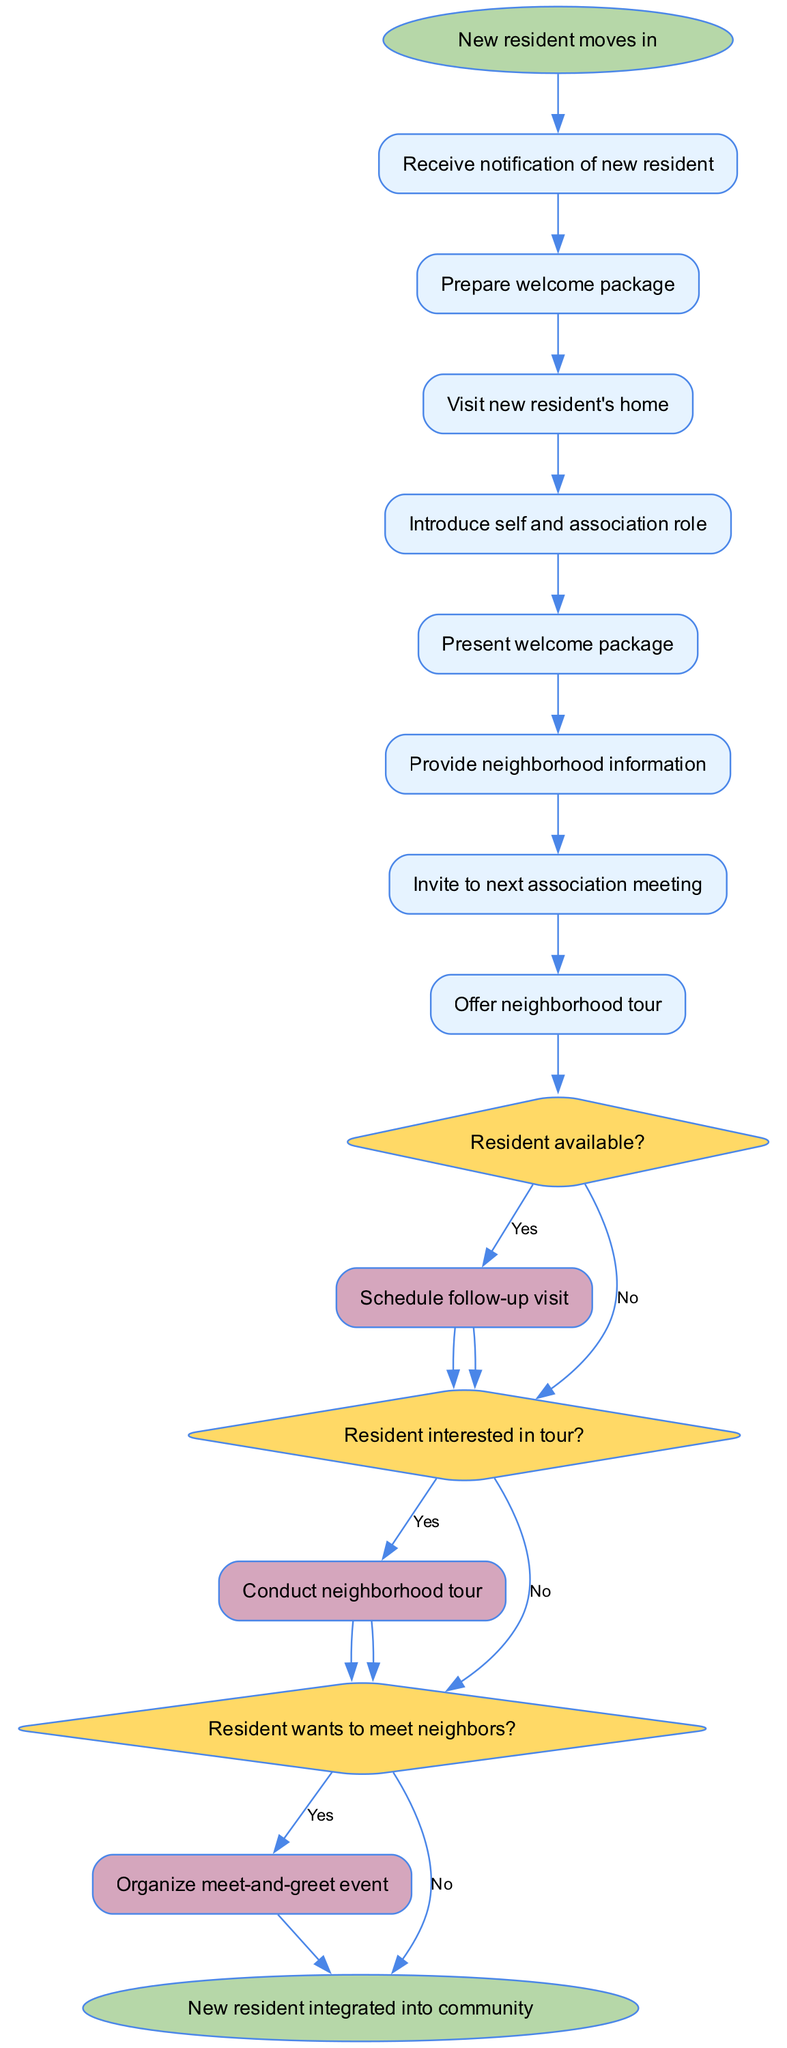What is the first action taken when a new resident moves in? The first action indicated in the diagram after the start node is "Receive notification of new resident." This is the very first step in the welcoming process before any further actions are taken.
Answer: Receive notification of new resident How many decisions are in the flowchart? The flowchart contains three decision nodes. Each of these decisions pertains to the availability and interests of the resident, which are crucial for deciding subsequent actions.
Answer: 3 What happens if the resident is not available? If the resident is not available at a particular decision point, the flowchart leads directly to the end node, indicating that no further actions can occur without the resident's availability.
Answer: End What action follows the decision of whether the resident is interested in a tour? If the resident is interested in a tour (the "Yes" branch from that decision), the next action taken is "Conduct neighborhood tour." This means a specific subprocess is activated to provide the tour.
Answer: Conduct neighborhood tour How many nodes are there in total? The total number of nodes includes all the action nodes, decision nodes, subprocess nodes, and the start and end nodes together. After counting each type of node, the total comes to ten.
Answer: 10 What is the purpose of the 'Organize meet-and-greet event' subprocess? The purpose of this subprocess is to facilitate the resident's desire to meet neighbors. Once the decision confirming the resident's interest is made, this subprocess is engaged to enhance community integration.
Answer: Meet neighbors What is the last action listed in the flowchart? The flowchart ends with the node labeled "New resident integrated into community." This is the final outcome after all preceding actions and decisions have been followed.
Answer: New resident integrated into community What does the 'Schedule follow-up visit' subprocess indicate? The 'Schedule follow-up visit' subprocess indicates that there will be an additional visit to the resident’s home if they express interest in meeting neighbors, ensuring ongoing engagement and support.
Answer: Follow-up visit What triggers the action 'Provide neighborhood information'? The action 'Provide neighborhood information' is triggered as part of the sequence that follows the primary introduction and presentation of the welcome package to the new resident. Therefore, it occurs before moving to any decisions.
Answer: Welcome package 